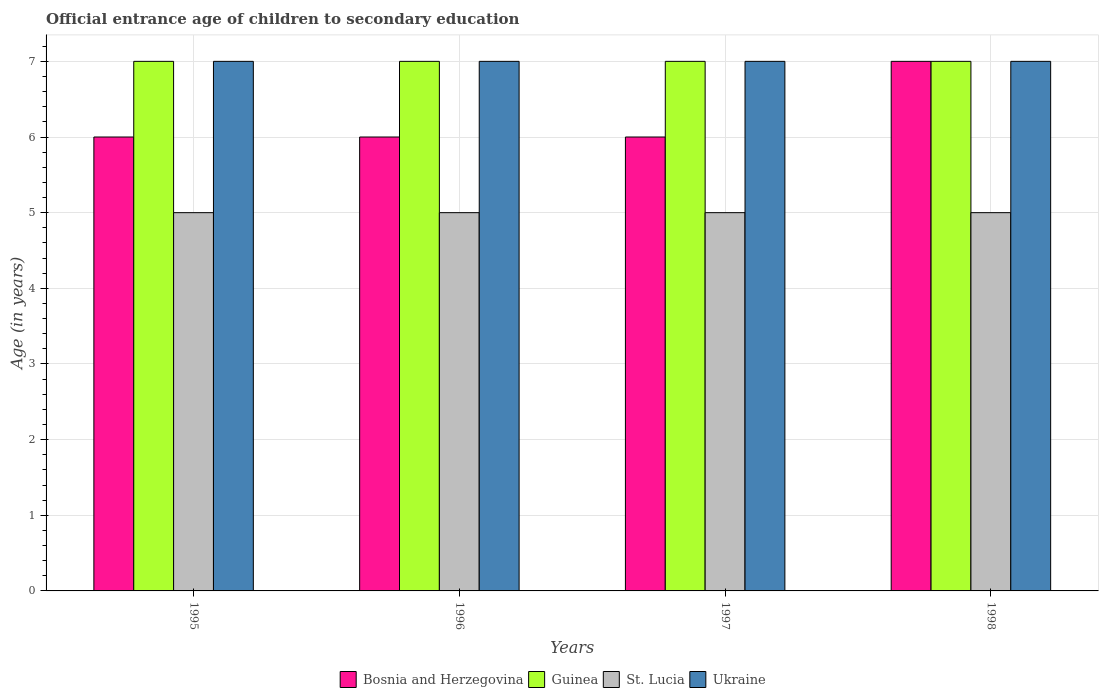How many different coloured bars are there?
Make the answer very short. 4. Are the number of bars per tick equal to the number of legend labels?
Offer a terse response. Yes. Are the number of bars on each tick of the X-axis equal?
Your answer should be compact. Yes. How many bars are there on the 3rd tick from the left?
Provide a short and direct response. 4. How many bars are there on the 2nd tick from the right?
Your response must be concise. 4. What is the label of the 3rd group of bars from the left?
Offer a very short reply. 1997. What is the secondary school starting age of children in St. Lucia in 1996?
Offer a terse response. 5. Across all years, what is the maximum secondary school starting age of children in Bosnia and Herzegovina?
Keep it short and to the point. 7. Across all years, what is the minimum secondary school starting age of children in Ukraine?
Provide a succinct answer. 7. In which year was the secondary school starting age of children in Bosnia and Herzegovina minimum?
Offer a terse response. 1995. What is the total secondary school starting age of children in St. Lucia in the graph?
Your answer should be very brief. 20. What is the difference between the secondary school starting age of children in Guinea in 1997 and the secondary school starting age of children in Bosnia and Herzegovina in 1995?
Offer a very short reply. 1. In the year 1995, what is the difference between the secondary school starting age of children in Bosnia and Herzegovina and secondary school starting age of children in Guinea?
Make the answer very short. -1. Is the difference between the secondary school starting age of children in Bosnia and Herzegovina in 1996 and 1997 greater than the difference between the secondary school starting age of children in Guinea in 1996 and 1997?
Offer a very short reply. No. What is the difference between the highest and the lowest secondary school starting age of children in Bosnia and Herzegovina?
Offer a very short reply. 1. Is the sum of the secondary school starting age of children in Guinea in 1995 and 1997 greater than the maximum secondary school starting age of children in Ukraine across all years?
Provide a short and direct response. Yes. Is it the case that in every year, the sum of the secondary school starting age of children in Ukraine and secondary school starting age of children in Guinea is greater than the sum of secondary school starting age of children in Bosnia and Herzegovina and secondary school starting age of children in St. Lucia?
Ensure brevity in your answer.  No. What does the 3rd bar from the left in 1995 represents?
Ensure brevity in your answer.  St. Lucia. What does the 2nd bar from the right in 1996 represents?
Your answer should be very brief. St. Lucia. How many bars are there?
Make the answer very short. 16. Are all the bars in the graph horizontal?
Provide a succinct answer. No. Are the values on the major ticks of Y-axis written in scientific E-notation?
Make the answer very short. No. Does the graph contain grids?
Provide a short and direct response. Yes. How many legend labels are there?
Your response must be concise. 4. How are the legend labels stacked?
Provide a short and direct response. Horizontal. What is the title of the graph?
Give a very brief answer. Official entrance age of children to secondary education. What is the label or title of the Y-axis?
Offer a very short reply. Age (in years). What is the Age (in years) in St. Lucia in 1995?
Your answer should be very brief. 5. What is the Age (in years) in Bosnia and Herzegovina in 1996?
Keep it short and to the point. 6. What is the Age (in years) of St. Lucia in 1996?
Make the answer very short. 5. What is the Age (in years) in Guinea in 1997?
Provide a short and direct response. 7. What is the Age (in years) in St. Lucia in 1997?
Your answer should be compact. 5. What is the Age (in years) in Bosnia and Herzegovina in 1998?
Give a very brief answer. 7. What is the Age (in years) of Guinea in 1998?
Provide a short and direct response. 7. What is the Age (in years) in Ukraine in 1998?
Your response must be concise. 7. Across all years, what is the maximum Age (in years) in Guinea?
Offer a terse response. 7. What is the total Age (in years) in St. Lucia in the graph?
Give a very brief answer. 20. What is the total Age (in years) of Ukraine in the graph?
Keep it short and to the point. 28. What is the difference between the Age (in years) in Bosnia and Herzegovina in 1995 and that in 1997?
Keep it short and to the point. 0. What is the difference between the Age (in years) in Guinea in 1995 and that in 1997?
Provide a short and direct response. 0. What is the difference between the Age (in years) of Ukraine in 1995 and that in 1997?
Offer a terse response. 0. What is the difference between the Age (in years) of Guinea in 1995 and that in 1998?
Offer a very short reply. 0. What is the difference between the Age (in years) of Bosnia and Herzegovina in 1996 and that in 1997?
Provide a succinct answer. 0. What is the difference between the Age (in years) of Guinea in 1996 and that in 1997?
Offer a terse response. 0. What is the difference between the Age (in years) of St. Lucia in 1996 and that in 1997?
Your answer should be compact. 0. What is the difference between the Age (in years) in Ukraine in 1996 and that in 1997?
Offer a very short reply. 0. What is the difference between the Age (in years) of Bosnia and Herzegovina in 1996 and that in 1998?
Your answer should be compact. -1. What is the difference between the Age (in years) of St. Lucia in 1996 and that in 1998?
Offer a very short reply. 0. What is the difference between the Age (in years) of Ukraine in 1996 and that in 1998?
Provide a short and direct response. 0. What is the difference between the Age (in years) of St. Lucia in 1997 and that in 1998?
Provide a succinct answer. 0. What is the difference between the Age (in years) of Bosnia and Herzegovina in 1995 and the Age (in years) of Guinea in 1996?
Your answer should be compact. -1. What is the difference between the Age (in years) of Bosnia and Herzegovina in 1995 and the Age (in years) of St. Lucia in 1996?
Give a very brief answer. 1. What is the difference between the Age (in years) of Guinea in 1995 and the Age (in years) of St. Lucia in 1996?
Keep it short and to the point. 2. What is the difference between the Age (in years) in Bosnia and Herzegovina in 1995 and the Age (in years) in Ukraine in 1997?
Provide a short and direct response. -1. What is the difference between the Age (in years) in Guinea in 1995 and the Age (in years) in Ukraine in 1997?
Your answer should be very brief. 0. What is the difference between the Age (in years) of St. Lucia in 1995 and the Age (in years) of Ukraine in 1997?
Give a very brief answer. -2. What is the difference between the Age (in years) in Bosnia and Herzegovina in 1996 and the Age (in years) in Guinea in 1997?
Your answer should be compact. -1. What is the difference between the Age (in years) of Bosnia and Herzegovina in 1996 and the Age (in years) of St. Lucia in 1997?
Provide a short and direct response. 1. What is the difference between the Age (in years) of St. Lucia in 1996 and the Age (in years) of Ukraine in 1997?
Your answer should be compact. -2. What is the difference between the Age (in years) in Bosnia and Herzegovina in 1996 and the Age (in years) in Guinea in 1998?
Make the answer very short. -1. What is the difference between the Age (in years) in Bosnia and Herzegovina in 1996 and the Age (in years) in Ukraine in 1998?
Provide a short and direct response. -1. What is the difference between the Age (in years) of Guinea in 1996 and the Age (in years) of St. Lucia in 1998?
Provide a succinct answer. 2. What is the difference between the Age (in years) of Guinea in 1996 and the Age (in years) of Ukraine in 1998?
Your response must be concise. 0. What is the difference between the Age (in years) in Bosnia and Herzegovina in 1997 and the Age (in years) in Guinea in 1998?
Your answer should be compact. -1. What is the difference between the Age (in years) of Guinea in 1997 and the Age (in years) of St. Lucia in 1998?
Your answer should be very brief. 2. What is the average Age (in years) in Bosnia and Herzegovina per year?
Your response must be concise. 6.25. In the year 1995, what is the difference between the Age (in years) in Bosnia and Herzegovina and Age (in years) in Guinea?
Ensure brevity in your answer.  -1. In the year 1995, what is the difference between the Age (in years) of Bosnia and Herzegovina and Age (in years) of St. Lucia?
Offer a terse response. 1. In the year 1995, what is the difference between the Age (in years) of Guinea and Age (in years) of St. Lucia?
Offer a very short reply. 2. In the year 1995, what is the difference between the Age (in years) of Guinea and Age (in years) of Ukraine?
Give a very brief answer. 0. In the year 1995, what is the difference between the Age (in years) in St. Lucia and Age (in years) in Ukraine?
Provide a short and direct response. -2. In the year 1996, what is the difference between the Age (in years) of Bosnia and Herzegovina and Age (in years) of St. Lucia?
Provide a short and direct response. 1. In the year 1996, what is the difference between the Age (in years) in Guinea and Age (in years) in St. Lucia?
Your answer should be compact. 2. In the year 1996, what is the difference between the Age (in years) in Guinea and Age (in years) in Ukraine?
Make the answer very short. 0. In the year 1997, what is the difference between the Age (in years) in Bosnia and Herzegovina and Age (in years) in Ukraine?
Give a very brief answer. -1. In the year 1997, what is the difference between the Age (in years) of Guinea and Age (in years) of Ukraine?
Your response must be concise. 0. In the year 1998, what is the difference between the Age (in years) of Bosnia and Herzegovina and Age (in years) of Guinea?
Provide a succinct answer. 0. In the year 1998, what is the difference between the Age (in years) in Bosnia and Herzegovina and Age (in years) in Ukraine?
Give a very brief answer. 0. What is the ratio of the Age (in years) of St. Lucia in 1995 to that in 1996?
Your answer should be very brief. 1. What is the ratio of the Age (in years) in Ukraine in 1995 to that in 1996?
Ensure brevity in your answer.  1. What is the ratio of the Age (in years) of Guinea in 1995 to that in 1997?
Your answer should be compact. 1. What is the ratio of the Age (in years) in Bosnia and Herzegovina in 1995 to that in 1998?
Provide a succinct answer. 0.86. What is the ratio of the Age (in years) of Guinea in 1995 to that in 1998?
Keep it short and to the point. 1. What is the ratio of the Age (in years) of Bosnia and Herzegovina in 1996 to that in 1997?
Provide a succinct answer. 1. What is the ratio of the Age (in years) in Guinea in 1996 to that in 1997?
Keep it short and to the point. 1. What is the ratio of the Age (in years) in Ukraine in 1996 to that in 1997?
Your answer should be very brief. 1. What is the ratio of the Age (in years) in Bosnia and Herzegovina in 1996 to that in 1998?
Give a very brief answer. 0.86. What is the ratio of the Age (in years) in Ukraine in 1996 to that in 1998?
Offer a terse response. 1. What is the ratio of the Age (in years) of Guinea in 1997 to that in 1998?
Your response must be concise. 1. What is the ratio of the Age (in years) in Ukraine in 1997 to that in 1998?
Ensure brevity in your answer.  1. What is the difference between the highest and the second highest Age (in years) in Guinea?
Offer a very short reply. 0. What is the difference between the highest and the second highest Age (in years) in St. Lucia?
Keep it short and to the point. 0. What is the difference between the highest and the lowest Age (in years) in Bosnia and Herzegovina?
Your answer should be compact. 1. What is the difference between the highest and the lowest Age (in years) of Guinea?
Make the answer very short. 0. What is the difference between the highest and the lowest Age (in years) of St. Lucia?
Offer a very short reply. 0. 